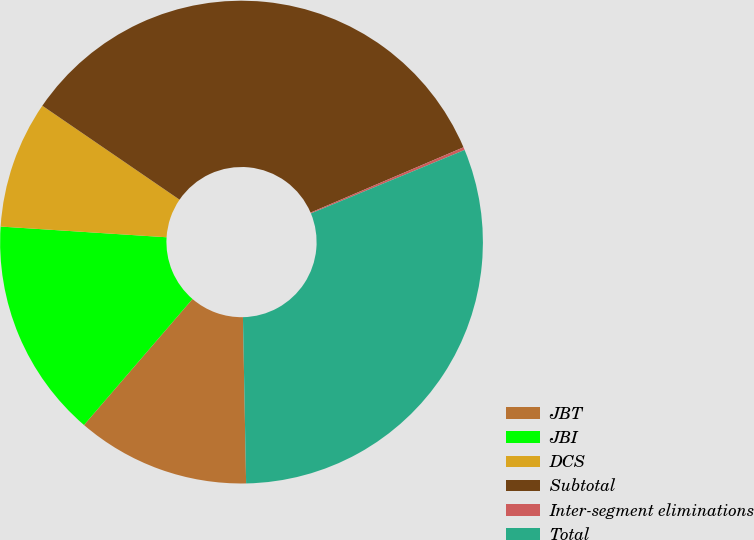Convert chart. <chart><loc_0><loc_0><loc_500><loc_500><pie_chart><fcel>JBT<fcel>JBI<fcel>DCS<fcel>Subtotal<fcel>Inter-segment eliminations<fcel>Total<nl><fcel>11.62%<fcel>14.71%<fcel>8.53%<fcel>34.02%<fcel>0.19%<fcel>30.93%<nl></chart> 